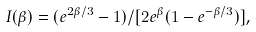Convert formula to latex. <formula><loc_0><loc_0><loc_500><loc_500>I ( \beta ) = ( e ^ { 2 \beta / 3 } - 1 ) / [ 2 e ^ { \beta } ( 1 - e ^ { - \beta / 3 } ) ] ,</formula> 